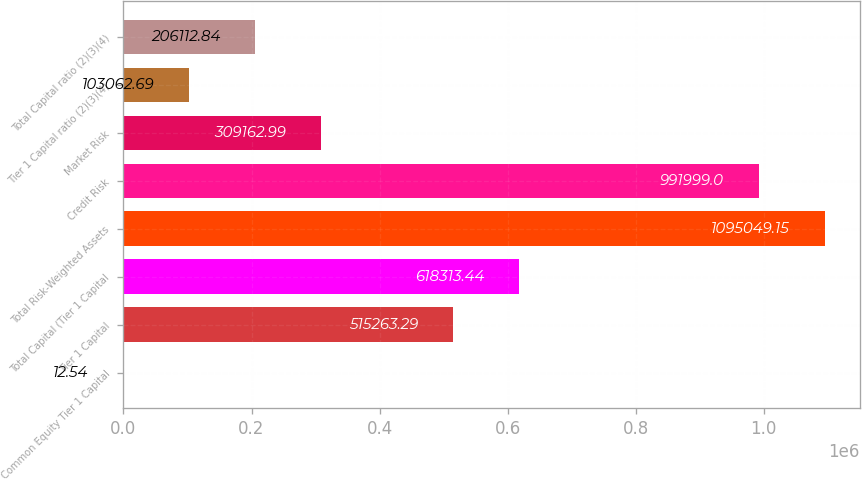Convert chart. <chart><loc_0><loc_0><loc_500><loc_500><bar_chart><fcel>Common Equity Tier 1 Capital<fcel>Tier 1 Capital<fcel>Total Capital (Tier 1 Capital<fcel>Total Risk-Weighted Assets<fcel>Credit Risk<fcel>Market Risk<fcel>Tier 1 Capital ratio (2)(3)(4)<fcel>Total Capital ratio (2)(3)(4)<nl><fcel>12.54<fcel>515263<fcel>618313<fcel>1.09505e+06<fcel>991999<fcel>309163<fcel>103063<fcel>206113<nl></chart> 